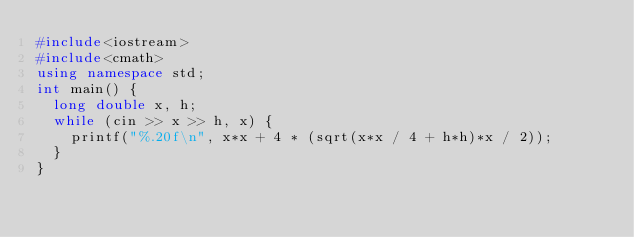Convert code to text. <code><loc_0><loc_0><loc_500><loc_500><_C++_>#include<iostream>
#include<cmath>
using namespace std;
int main() {
	long double x, h;
	while (cin >> x >> h, x) {
		printf("%.20f\n", x*x + 4 * (sqrt(x*x / 4 + h*h)*x / 2));
	}
}</code> 